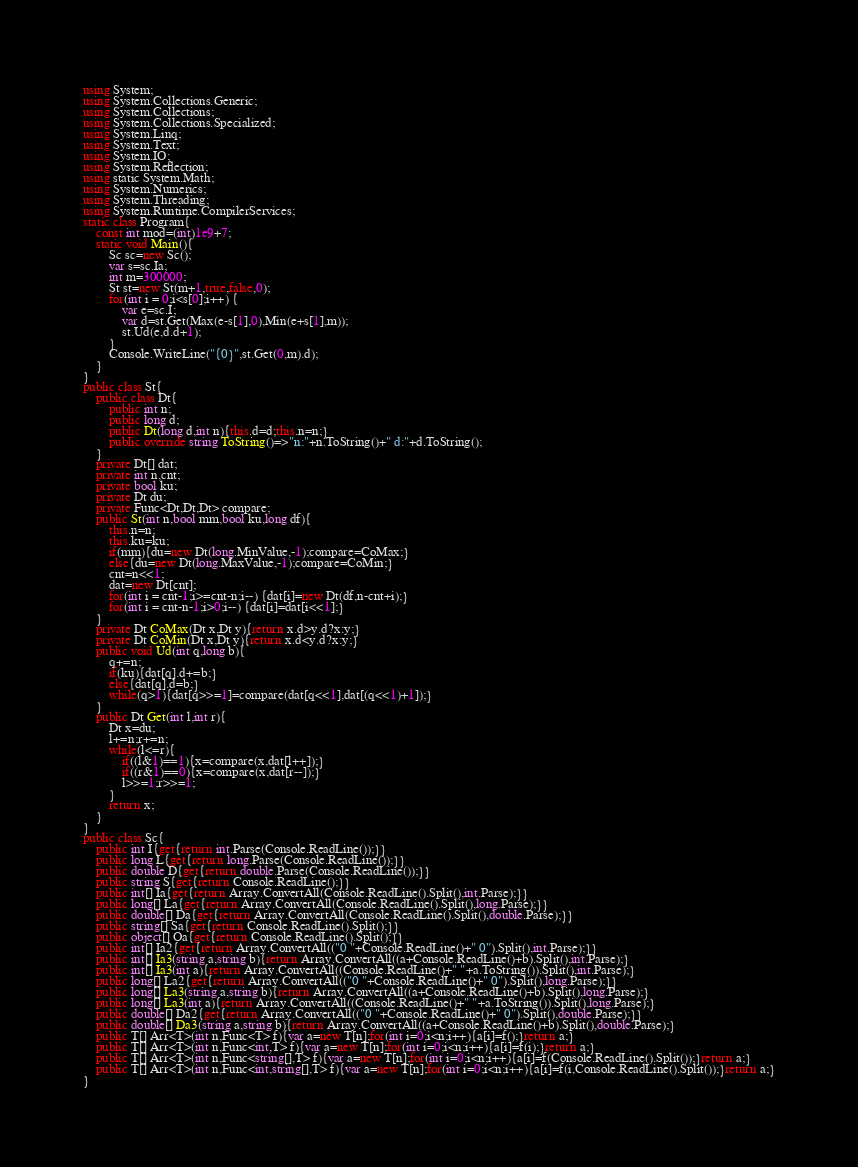Convert code to text. <code><loc_0><loc_0><loc_500><loc_500><_C#_>using System;
using System.Collections.Generic;
using System.Collections;
using System.Collections.Specialized;
using System.Linq;
using System.Text;
using System.IO;
using System.Reflection;
using static System.Math;
using System.Numerics;
using System.Threading;
using System.Runtime.CompilerServices;
static class Program{
	const int mod=(int)1e9+7;
	static void Main(){
		Sc sc=new Sc();
		var s=sc.Ia;
		int m=300000;
		St st=new St(m+1,true,false,0);
		for(int i = 0;i<s[0];i++) {
			var e=sc.I;
			var d=st.Get(Max(e-s[1],0),Min(e+s[1],m));
			st.Ud(e,d.d+1);
		}
		Console.WriteLine("{0}",st.Get(0,m).d);
	}
}
public class St{
	public class Dt{
		public int n;
		public long d;
		public Dt(long d,int n){this.d=d;this.n=n;}
		public override string ToString()=>"n:"+n.ToString()+" d:"+d.ToString();
	}
	private Dt[] dat;
	private int n,cnt;
	private bool ku;
	private Dt du;
	private Func<Dt,Dt,Dt> compare;
	public St(int n,bool mm,bool ku,long df){
		this.n=n;
		this.ku=ku;
		if(mm){du=new Dt(long.MinValue,-1);compare=CoMax;}
		else{du=new Dt(long.MaxValue,-1);compare=CoMin;}
		cnt=n<<1;
		dat=new Dt[cnt];
		for(int i = cnt-1;i>=cnt-n;i--) {dat[i]=new Dt(df,n-cnt+i);}
		for(int i = cnt-n-1;i>0;i--) {dat[i]=dat[i<<1];}
	}
	private Dt CoMax(Dt x,Dt y){return x.d>y.d?x:y;}
	private Dt CoMin(Dt x,Dt y){return x.d<y.d?x:y;}
	public void Ud(int q,long b){
		q+=n;
		if(ku){dat[q].d+=b;}
		else{dat[q].d=b;}
		while(q>1){dat[q>>=1]=compare(dat[q<<1],dat[(q<<1)+1]);}
	}
	public Dt Get(int l,int r){
		Dt x=du;
		l+=n;r+=n;
		while(l<=r){
			if((l&1)==1){x=compare(x,dat[l++]);}
			if((r&1)==0){x=compare(x,dat[r--]);}
			l>>=1;r>>=1;
		}
		return x;
	}
}
public class Sc{
	public int I{get{return int.Parse(Console.ReadLine());}}
	public long L{get{return long.Parse(Console.ReadLine());}}
	public double D{get{return double.Parse(Console.ReadLine());}}
	public string S{get{return Console.ReadLine();}}
	public int[] Ia{get{return Array.ConvertAll(Console.ReadLine().Split(),int.Parse);}}
	public long[] La{get{return Array.ConvertAll(Console.ReadLine().Split(),long.Parse);}}
	public double[] Da{get{return Array.ConvertAll(Console.ReadLine().Split(),double.Parse);}}
	public string[] Sa{get{return Console.ReadLine().Split();}}
	public object[] Oa{get{return Console.ReadLine().Split();}}
	public int[] Ia2{get{return Array.ConvertAll(("0 "+Console.ReadLine()+" 0").Split(),int.Parse);}}
	public int[] Ia3(string a,string b){return Array.ConvertAll((a+Console.ReadLine()+b).Split(),int.Parse);}
	public int[] Ia3(int a){return Array.ConvertAll((Console.ReadLine()+" "+a.ToString()).Split(),int.Parse);}
	public long[] La2{get{return Array.ConvertAll(("0 "+Console.ReadLine()+" 0").Split(),long.Parse);}}
	public long[] La3(string a,string b){return Array.ConvertAll((a+Console.ReadLine()+b).Split(),long.Parse);}
	public long[] La3(int a){return Array.ConvertAll((Console.ReadLine()+" "+a.ToString()).Split(),long.Parse);}
	public double[] Da2{get{return Array.ConvertAll(("0 "+Console.ReadLine()+" 0").Split(),double.Parse);}}
	public double[] Da3(string a,string b){return Array.ConvertAll((a+Console.ReadLine()+b).Split(),double.Parse);}
	public T[] Arr<T>(int n,Func<T> f){var a=new T[n];for(int i=0;i<n;i++){a[i]=f();}return a;}
	public T[] Arr<T>(int n,Func<int,T> f){var a=new T[n];for(int i=0;i<n;i++){a[i]=f(i);}return a;}
	public T[] Arr<T>(int n,Func<string[],T> f){var a=new T[n];for(int i=0;i<n;i++){a[i]=f(Console.ReadLine().Split());}return a;}
	public T[] Arr<T>(int n,Func<int,string[],T> f){var a=new T[n];for(int i=0;i<n;i++){a[i]=f(i,Console.ReadLine().Split());}return a;}
}</code> 